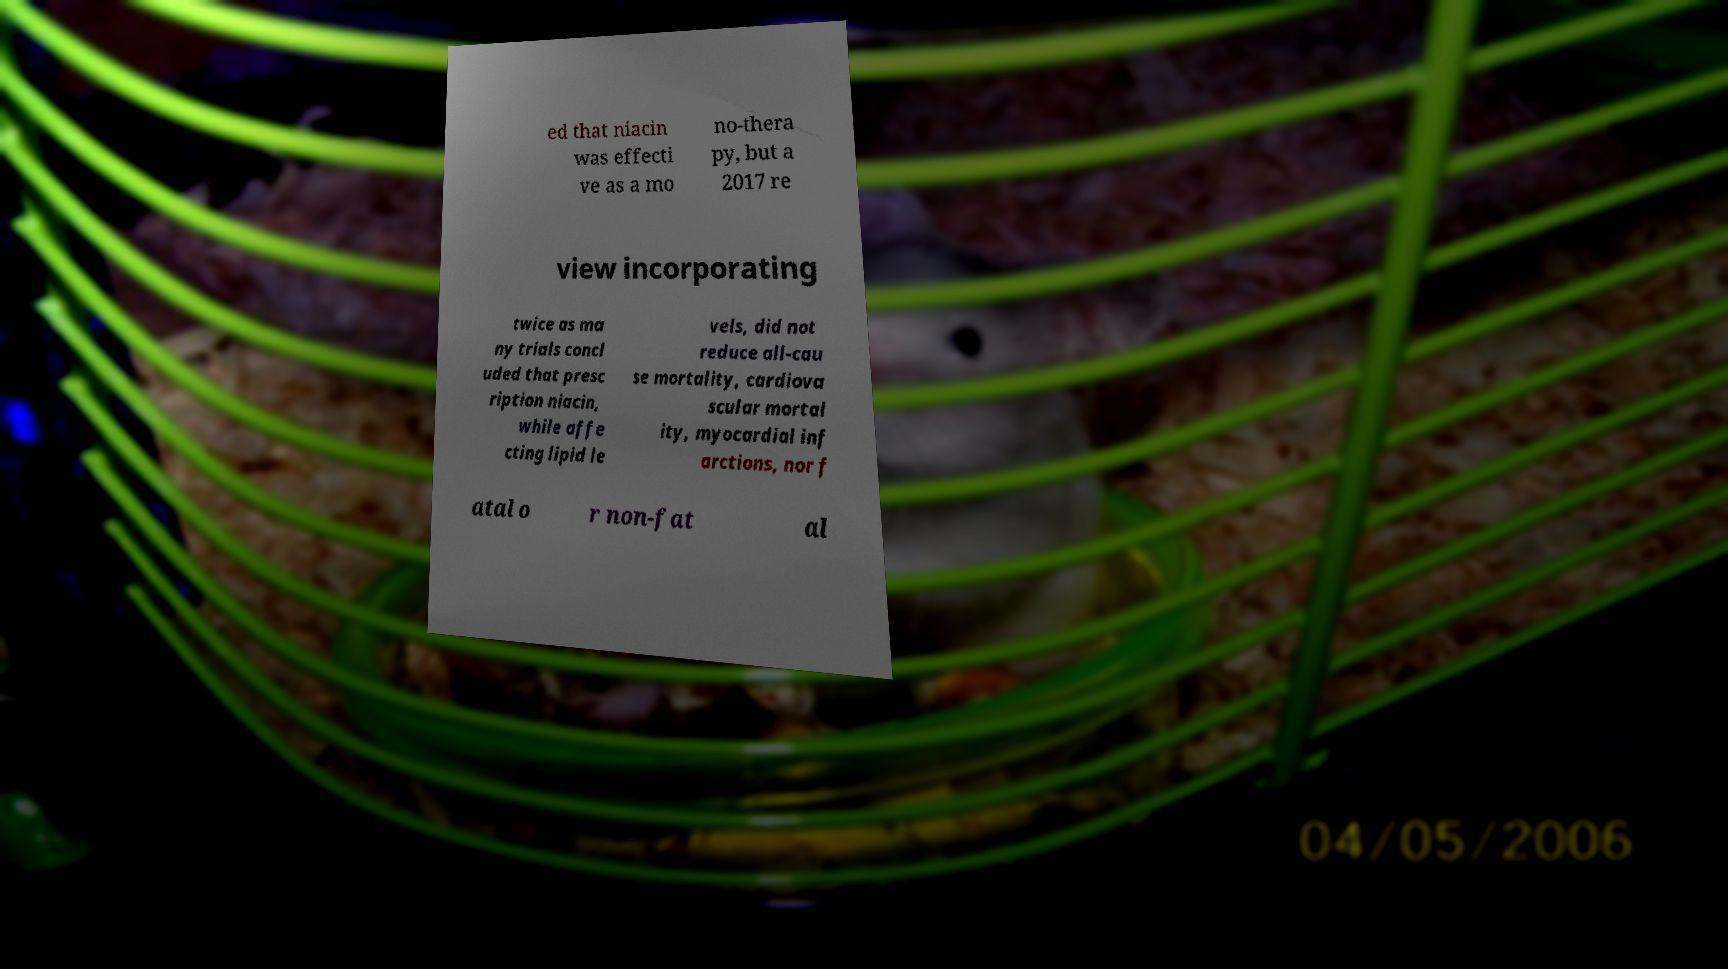What messages or text are displayed in this image? I need them in a readable, typed format. ed that niacin was effecti ve as a mo no-thera py, but a 2017 re view incorporating twice as ma ny trials concl uded that presc ription niacin, while affe cting lipid le vels, did not reduce all-cau se mortality, cardiova scular mortal ity, myocardial inf arctions, nor f atal o r non-fat al 